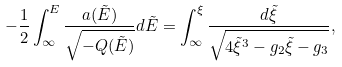Convert formula to latex. <formula><loc_0><loc_0><loc_500><loc_500>- \frac { 1 } { 2 } \int _ { \infty } ^ { E } \frac { a ( \tilde { E } ) } { \sqrt { - Q ( \tilde { E } ) } } d \tilde { E } = \int _ { \infty } ^ { \xi } \frac { d \tilde { \xi } } { \sqrt { 4 \tilde { \xi } ^ { 3 } - g _ { 2 } \tilde { \xi } - g _ { 3 } } } ,</formula> 